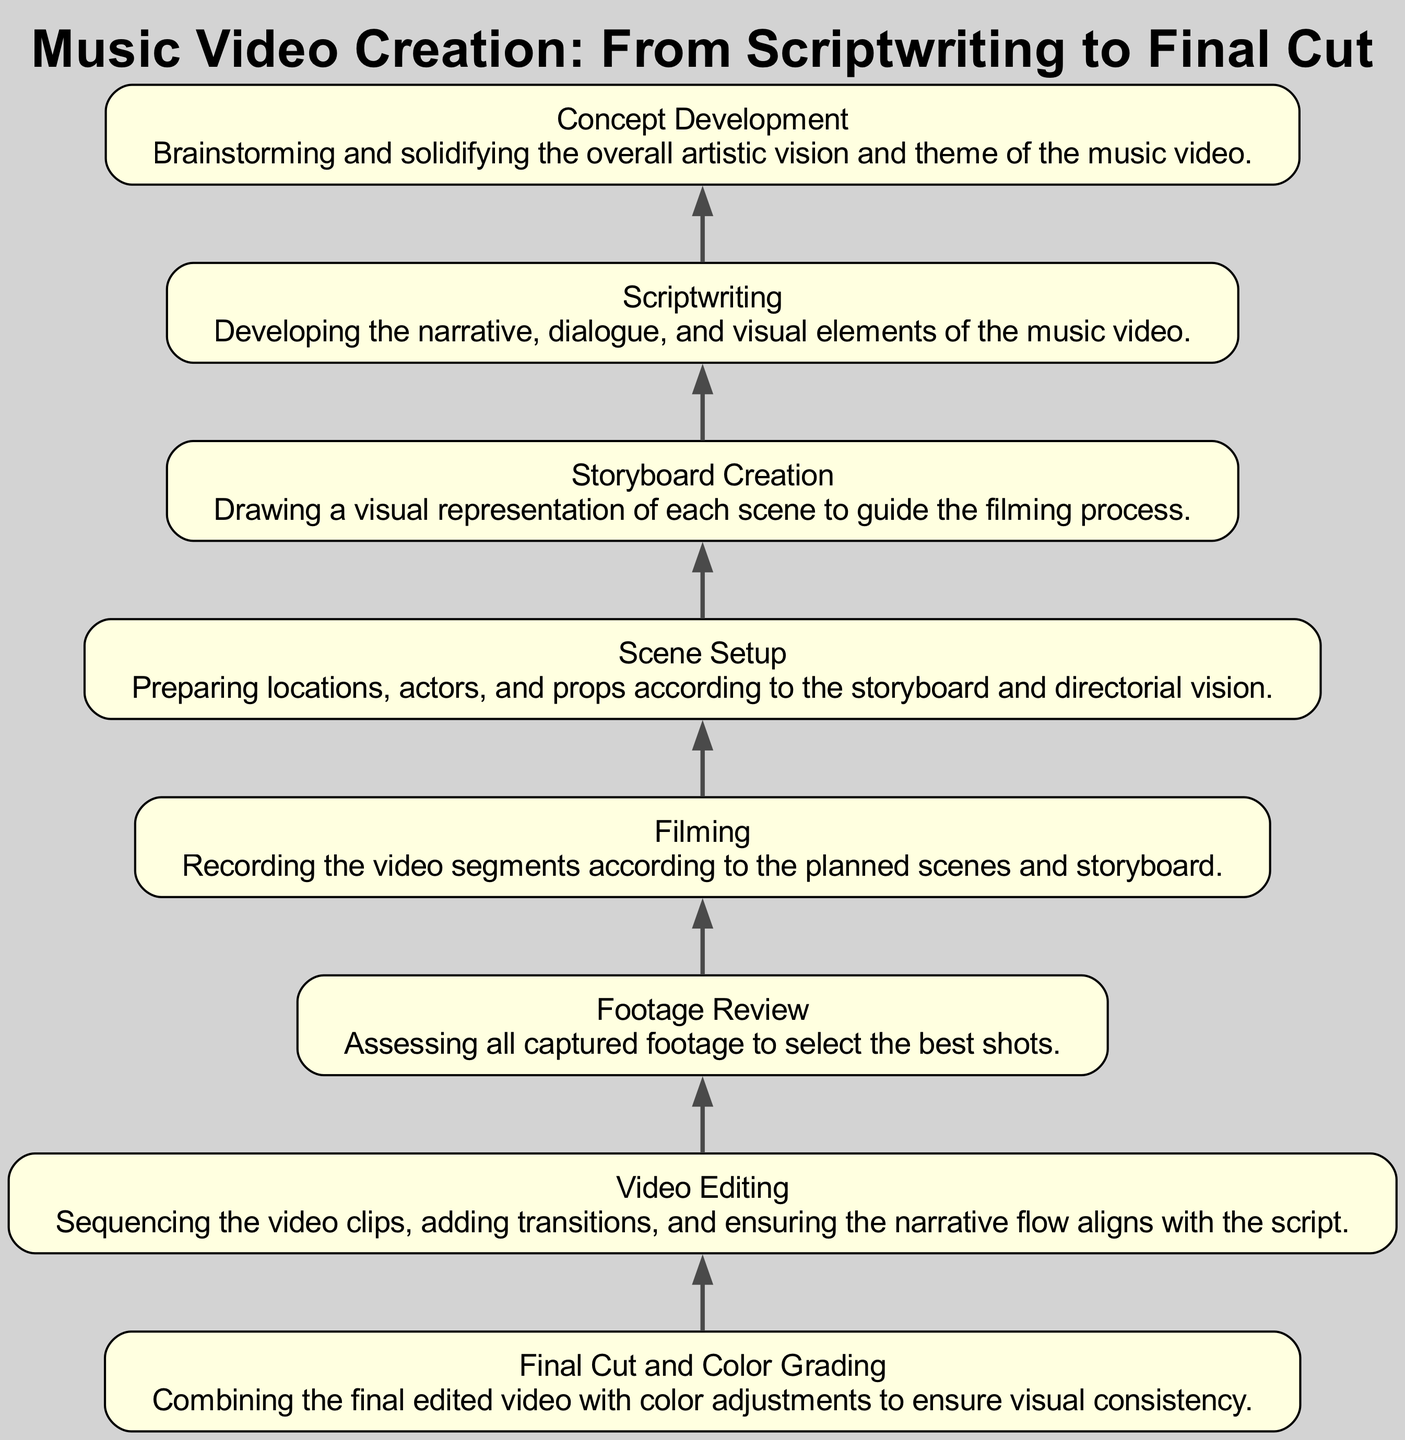What is the last step in the music video creation process? The last step in the process as depicted in the diagram is "Final Cut and Color Grading." This is the final node at the top of the flowchart, indicating it is the concluding phase of the music video creation.
Answer: Final Cut and Color Grading How many steps are there in total in the music video creation process? By counting the individual nodes in the diagram, there are eight specific steps (nodes) depicted in the flowchart from "Concept Development" to "Final Cut and Color Grading."
Answer: Eight What precedes the "Video Editing" step? The diagram shows that the "Footage Review" step comes directly before "Video Editing." This indicates that reviewing the footage is necessary before the editing process begins.
Answer: Footage Review What is the first step of the music video creation process? According to the flowchart, the first step is "Concept Development," which is the bottom-most node and sets the foundation for all subsequent steps.
Answer: Concept Development Which two steps connect "Filming" with "Footage Review"? The steps that connect "Filming" with "Footage Review" are "Scene Setup," which occurs directly before filming, and “Filming” itself, which leads directly to "Footage Review." This shows that scene preparation is essential before filming.
Answer: Scene Setup, Filming Which step focuses on developing narrative elements? The step that specifically focuses on developing narrative elements in the music video creation process is "Scriptwriting," as stated in its description within the diagram.
Answer: Scriptwriting How does "Storyboard Creation" relate to "Filming"? "Storyboard Creation" precedes "Filming" in the flowchart, indicating that a visual plan through storyboarding is necessary before the actual filming takes place; it provides a guide for filming.
Answer: Storyboard Creation What is required before "Final Cut and Color Grading"? The step that must be completed before "Final Cut and Color Grading" is "Video Editing," as it allows for sequencing and refining the video content, which is finalized during the color grading process.
Answer: Video Editing 